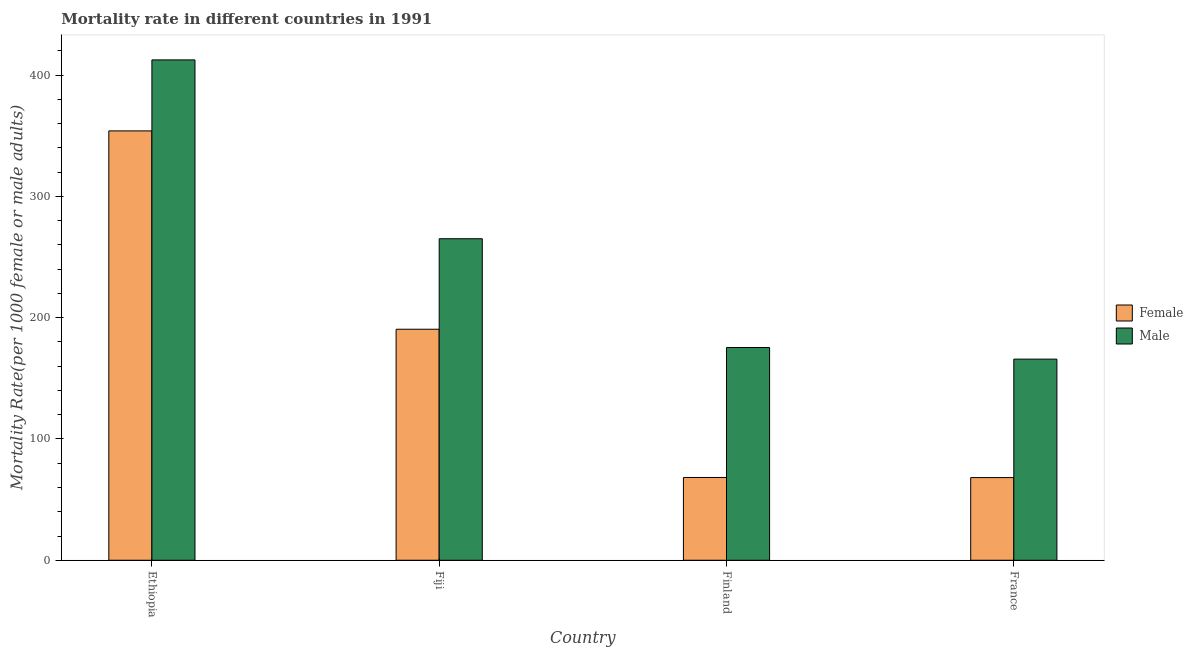How many groups of bars are there?
Give a very brief answer. 4. Are the number of bars per tick equal to the number of legend labels?
Your answer should be compact. Yes. How many bars are there on the 3rd tick from the left?
Your response must be concise. 2. What is the female mortality rate in Fiji?
Provide a short and direct response. 190.5. Across all countries, what is the maximum female mortality rate?
Ensure brevity in your answer.  354.07. Across all countries, what is the minimum male mortality rate?
Ensure brevity in your answer.  165.85. In which country was the female mortality rate maximum?
Offer a terse response. Ethiopia. What is the total male mortality rate in the graph?
Give a very brief answer. 1019.06. What is the difference between the female mortality rate in Finland and that in France?
Your answer should be compact. 0.08. What is the difference between the male mortality rate in Ethiopia and the female mortality rate in France?
Offer a very short reply. 344.44. What is the average female mortality rate per country?
Give a very brief answer. 170.25. What is the difference between the male mortality rate and female mortality rate in Ethiopia?
Your answer should be compact. 58.56. What is the ratio of the male mortality rate in Fiji to that in France?
Provide a short and direct response. 1.6. Is the male mortality rate in Fiji less than that in France?
Give a very brief answer. No. What is the difference between the highest and the second highest male mortality rate?
Keep it short and to the point. 147.48. What is the difference between the highest and the lowest female mortality rate?
Provide a short and direct response. 285.89. In how many countries, is the male mortality rate greater than the average male mortality rate taken over all countries?
Provide a succinct answer. 2. What does the 1st bar from the left in Fiji represents?
Give a very brief answer. Female. What does the 1st bar from the right in Fiji represents?
Ensure brevity in your answer.  Male. How many bars are there?
Offer a very short reply. 8. What is the difference between two consecutive major ticks on the Y-axis?
Give a very brief answer. 100. Does the graph contain any zero values?
Your answer should be very brief. No. Where does the legend appear in the graph?
Offer a very short reply. Center right. How many legend labels are there?
Give a very brief answer. 2. What is the title of the graph?
Provide a succinct answer. Mortality rate in different countries in 1991. Does "Merchandise imports" appear as one of the legend labels in the graph?
Make the answer very short. No. What is the label or title of the X-axis?
Keep it short and to the point. Country. What is the label or title of the Y-axis?
Give a very brief answer. Mortality Rate(per 1000 female or male adults). What is the Mortality Rate(per 1000 female or male adults) of Female in Ethiopia?
Offer a very short reply. 354.07. What is the Mortality Rate(per 1000 female or male adults) of Male in Ethiopia?
Provide a short and direct response. 412.62. What is the Mortality Rate(per 1000 female or male adults) of Female in Fiji?
Provide a short and direct response. 190.5. What is the Mortality Rate(per 1000 female or male adults) of Male in Fiji?
Keep it short and to the point. 265.15. What is the Mortality Rate(per 1000 female or male adults) in Female in Finland?
Make the answer very short. 68.26. What is the Mortality Rate(per 1000 female or male adults) of Male in Finland?
Give a very brief answer. 175.44. What is the Mortality Rate(per 1000 female or male adults) of Female in France?
Your response must be concise. 68.18. What is the Mortality Rate(per 1000 female or male adults) of Male in France?
Offer a terse response. 165.85. Across all countries, what is the maximum Mortality Rate(per 1000 female or male adults) in Female?
Make the answer very short. 354.07. Across all countries, what is the maximum Mortality Rate(per 1000 female or male adults) of Male?
Ensure brevity in your answer.  412.62. Across all countries, what is the minimum Mortality Rate(per 1000 female or male adults) in Female?
Offer a terse response. 68.18. Across all countries, what is the minimum Mortality Rate(per 1000 female or male adults) of Male?
Make the answer very short. 165.85. What is the total Mortality Rate(per 1000 female or male adults) of Female in the graph?
Your answer should be very brief. 681.01. What is the total Mortality Rate(per 1000 female or male adults) in Male in the graph?
Your answer should be very brief. 1019.06. What is the difference between the Mortality Rate(per 1000 female or male adults) of Female in Ethiopia and that in Fiji?
Your answer should be very brief. 163.56. What is the difference between the Mortality Rate(per 1000 female or male adults) in Male in Ethiopia and that in Fiji?
Offer a terse response. 147.48. What is the difference between the Mortality Rate(per 1000 female or male adults) of Female in Ethiopia and that in Finland?
Provide a succinct answer. 285.81. What is the difference between the Mortality Rate(per 1000 female or male adults) of Male in Ethiopia and that in Finland?
Keep it short and to the point. 237.19. What is the difference between the Mortality Rate(per 1000 female or male adults) of Female in Ethiopia and that in France?
Give a very brief answer. 285.89. What is the difference between the Mortality Rate(per 1000 female or male adults) of Male in Ethiopia and that in France?
Your answer should be very brief. 246.77. What is the difference between the Mortality Rate(per 1000 female or male adults) in Female in Fiji and that in Finland?
Your answer should be compact. 122.24. What is the difference between the Mortality Rate(per 1000 female or male adults) in Male in Fiji and that in Finland?
Your response must be concise. 89.71. What is the difference between the Mortality Rate(per 1000 female or male adults) in Female in Fiji and that in France?
Offer a terse response. 122.32. What is the difference between the Mortality Rate(per 1000 female or male adults) in Male in Fiji and that in France?
Your answer should be compact. 99.29. What is the difference between the Mortality Rate(per 1000 female or male adults) of Female in Finland and that in France?
Provide a succinct answer. 0.08. What is the difference between the Mortality Rate(per 1000 female or male adults) in Male in Finland and that in France?
Provide a short and direct response. 9.58. What is the difference between the Mortality Rate(per 1000 female or male adults) of Female in Ethiopia and the Mortality Rate(per 1000 female or male adults) of Male in Fiji?
Provide a succinct answer. 88.92. What is the difference between the Mortality Rate(per 1000 female or male adults) in Female in Ethiopia and the Mortality Rate(per 1000 female or male adults) in Male in Finland?
Your answer should be compact. 178.63. What is the difference between the Mortality Rate(per 1000 female or male adults) of Female in Ethiopia and the Mortality Rate(per 1000 female or male adults) of Male in France?
Provide a succinct answer. 188.21. What is the difference between the Mortality Rate(per 1000 female or male adults) of Female in Fiji and the Mortality Rate(per 1000 female or male adults) of Male in Finland?
Provide a succinct answer. 15.07. What is the difference between the Mortality Rate(per 1000 female or male adults) in Female in Fiji and the Mortality Rate(per 1000 female or male adults) in Male in France?
Your answer should be very brief. 24.65. What is the difference between the Mortality Rate(per 1000 female or male adults) in Female in Finland and the Mortality Rate(per 1000 female or male adults) in Male in France?
Your response must be concise. -97.59. What is the average Mortality Rate(per 1000 female or male adults) of Female per country?
Keep it short and to the point. 170.25. What is the average Mortality Rate(per 1000 female or male adults) of Male per country?
Offer a terse response. 254.77. What is the difference between the Mortality Rate(per 1000 female or male adults) of Female and Mortality Rate(per 1000 female or male adults) of Male in Ethiopia?
Offer a terse response. -58.56. What is the difference between the Mortality Rate(per 1000 female or male adults) of Female and Mortality Rate(per 1000 female or male adults) of Male in Fiji?
Provide a succinct answer. -74.64. What is the difference between the Mortality Rate(per 1000 female or male adults) of Female and Mortality Rate(per 1000 female or male adults) of Male in Finland?
Provide a succinct answer. -107.17. What is the difference between the Mortality Rate(per 1000 female or male adults) in Female and Mortality Rate(per 1000 female or male adults) in Male in France?
Provide a succinct answer. -97.67. What is the ratio of the Mortality Rate(per 1000 female or male adults) of Female in Ethiopia to that in Fiji?
Your answer should be compact. 1.86. What is the ratio of the Mortality Rate(per 1000 female or male adults) in Male in Ethiopia to that in Fiji?
Your answer should be compact. 1.56. What is the ratio of the Mortality Rate(per 1000 female or male adults) of Female in Ethiopia to that in Finland?
Ensure brevity in your answer.  5.19. What is the ratio of the Mortality Rate(per 1000 female or male adults) of Male in Ethiopia to that in Finland?
Your answer should be compact. 2.35. What is the ratio of the Mortality Rate(per 1000 female or male adults) in Female in Ethiopia to that in France?
Provide a short and direct response. 5.19. What is the ratio of the Mortality Rate(per 1000 female or male adults) of Male in Ethiopia to that in France?
Your answer should be very brief. 2.49. What is the ratio of the Mortality Rate(per 1000 female or male adults) in Female in Fiji to that in Finland?
Give a very brief answer. 2.79. What is the ratio of the Mortality Rate(per 1000 female or male adults) in Male in Fiji to that in Finland?
Your response must be concise. 1.51. What is the ratio of the Mortality Rate(per 1000 female or male adults) of Female in Fiji to that in France?
Your answer should be very brief. 2.79. What is the ratio of the Mortality Rate(per 1000 female or male adults) in Male in Fiji to that in France?
Keep it short and to the point. 1.6. What is the ratio of the Mortality Rate(per 1000 female or male adults) of Female in Finland to that in France?
Keep it short and to the point. 1. What is the ratio of the Mortality Rate(per 1000 female or male adults) in Male in Finland to that in France?
Offer a terse response. 1.06. What is the difference between the highest and the second highest Mortality Rate(per 1000 female or male adults) in Female?
Provide a succinct answer. 163.56. What is the difference between the highest and the second highest Mortality Rate(per 1000 female or male adults) of Male?
Provide a succinct answer. 147.48. What is the difference between the highest and the lowest Mortality Rate(per 1000 female or male adults) of Female?
Provide a short and direct response. 285.89. What is the difference between the highest and the lowest Mortality Rate(per 1000 female or male adults) in Male?
Make the answer very short. 246.77. 